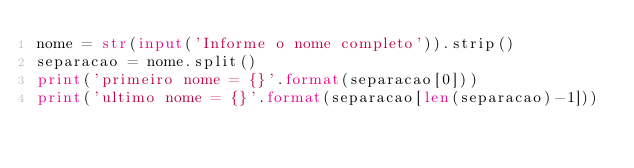Convert code to text. <code><loc_0><loc_0><loc_500><loc_500><_Python_>nome = str(input('Informe o nome completo')).strip()
separacao = nome.split()
print('primeiro nome = {}'.format(separacao[0]))
print('ultimo nome = {}'.format(separacao[len(separacao)-1]))
</code> 